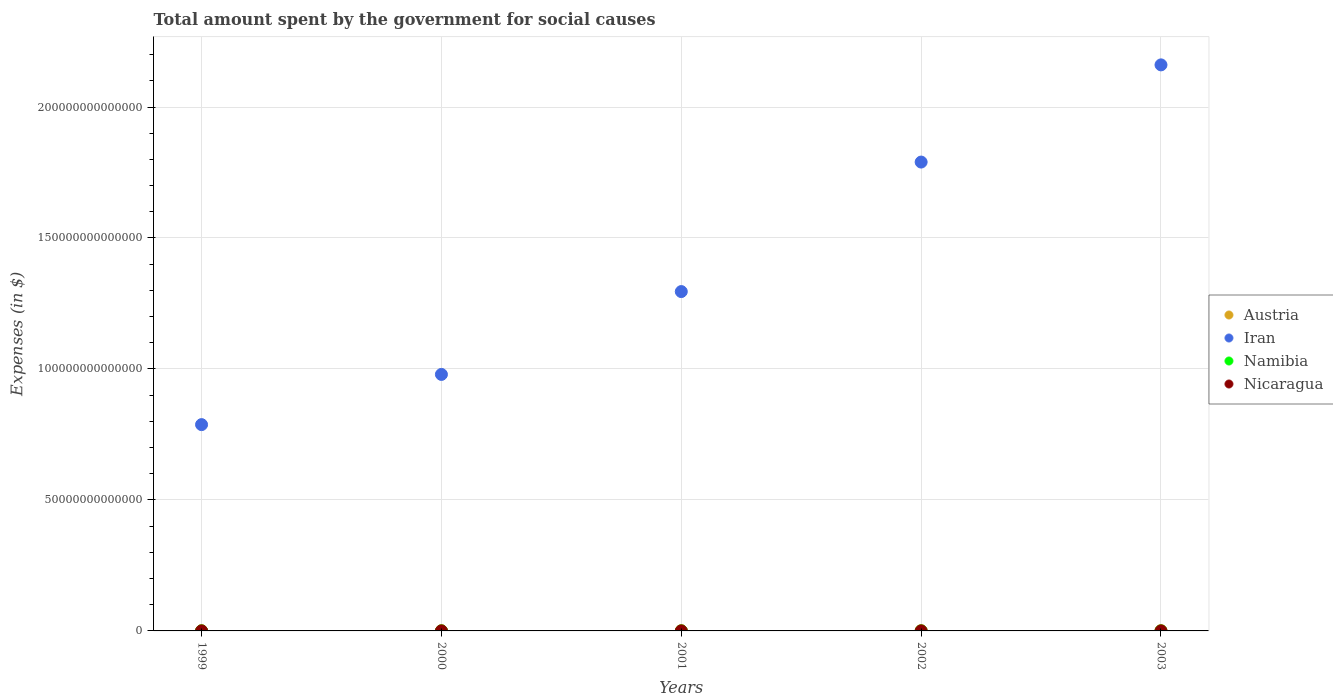How many different coloured dotlines are there?
Ensure brevity in your answer.  4. Is the number of dotlines equal to the number of legend labels?
Your answer should be compact. Yes. What is the amount spent for social causes by the government in Austria in 2002?
Keep it short and to the point. 8.88e+1. Across all years, what is the maximum amount spent for social causes by the government in Austria?
Your answer should be very brief. 9.14e+1. Across all years, what is the minimum amount spent for social causes by the government in Iran?
Ensure brevity in your answer.  7.88e+13. What is the total amount spent for social causes by the government in Iran in the graph?
Make the answer very short. 7.01e+14. What is the difference between the amount spent for social causes by the government in Austria in 2001 and that in 2002?
Your response must be concise. -1.54e+09. What is the difference between the amount spent for social causes by the government in Iran in 2002 and the amount spent for social causes by the government in Austria in 2000?
Your response must be concise. 1.79e+14. What is the average amount spent for social causes by the government in Namibia per year?
Your answer should be compact. 9.03e+09. In the year 2002, what is the difference between the amount spent for social causes by the government in Austria and amount spent for social causes by the government in Iran?
Provide a succinct answer. -1.79e+14. What is the ratio of the amount spent for social causes by the government in Austria in 1999 to that in 2003?
Your answer should be very brief. 0.9. Is the amount spent for social causes by the government in Nicaragua in 1999 less than that in 2001?
Your answer should be compact. Yes. What is the difference between the highest and the second highest amount spent for social causes by the government in Namibia?
Offer a very short reply. 8.63e+08. What is the difference between the highest and the lowest amount spent for social causes by the government in Austria?
Your response must be concise. 9.48e+09. Is the sum of the amount spent for social causes by the government in Iran in 2000 and 2001 greater than the maximum amount spent for social causes by the government in Nicaragua across all years?
Keep it short and to the point. Yes. Is it the case that in every year, the sum of the amount spent for social causes by the government in Nicaragua and amount spent for social causes by the government in Austria  is greater than the sum of amount spent for social causes by the government in Iran and amount spent for social causes by the government in Namibia?
Ensure brevity in your answer.  No. Does the amount spent for social causes by the government in Austria monotonically increase over the years?
Your response must be concise. Yes. Is the amount spent for social causes by the government in Nicaragua strictly less than the amount spent for social causes by the government in Austria over the years?
Offer a terse response. Yes. How many dotlines are there?
Your answer should be very brief. 4. What is the difference between two consecutive major ticks on the Y-axis?
Ensure brevity in your answer.  5.00e+13. How many legend labels are there?
Provide a succinct answer. 4. How are the legend labels stacked?
Your answer should be very brief. Vertical. What is the title of the graph?
Offer a terse response. Total amount spent by the government for social causes. What is the label or title of the X-axis?
Make the answer very short. Years. What is the label or title of the Y-axis?
Your answer should be very brief. Expenses (in $). What is the Expenses (in $) in Austria in 1999?
Provide a succinct answer. 8.19e+1. What is the Expenses (in $) in Iran in 1999?
Offer a very short reply. 7.88e+13. What is the Expenses (in $) of Namibia in 1999?
Your answer should be compact. 6.91e+09. What is the Expenses (in $) in Nicaragua in 1999?
Offer a terse response. 7.27e+09. What is the Expenses (in $) in Austria in 2000?
Offer a very short reply. 8.43e+1. What is the Expenses (in $) in Iran in 2000?
Ensure brevity in your answer.  9.79e+13. What is the Expenses (in $) in Namibia in 2000?
Your answer should be very brief. 7.73e+09. What is the Expenses (in $) in Nicaragua in 2000?
Ensure brevity in your answer.  8.23e+09. What is the Expenses (in $) of Austria in 2001?
Offer a very short reply. 8.72e+1. What is the Expenses (in $) of Iran in 2001?
Make the answer very short. 1.30e+14. What is the Expenses (in $) in Namibia in 2001?
Offer a terse response. 9.20e+09. What is the Expenses (in $) in Nicaragua in 2001?
Provide a short and direct response. 1.03e+1. What is the Expenses (in $) of Austria in 2002?
Your answer should be very brief. 8.88e+1. What is the Expenses (in $) of Iran in 2002?
Keep it short and to the point. 1.79e+14. What is the Expenses (in $) in Namibia in 2002?
Keep it short and to the point. 1.02e+1. What is the Expenses (in $) in Nicaragua in 2002?
Your answer should be compact. 9.08e+09. What is the Expenses (in $) of Austria in 2003?
Offer a terse response. 9.14e+1. What is the Expenses (in $) of Iran in 2003?
Your answer should be very brief. 2.16e+14. What is the Expenses (in $) in Namibia in 2003?
Offer a very short reply. 1.11e+1. What is the Expenses (in $) in Nicaragua in 2003?
Offer a terse response. 1.06e+1. Across all years, what is the maximum Expenses (in $) of Austria?
Provide a short and direct response. 9.14e+1. Across all years, what is the maximum Expenses (in $) in Iran?
Provide a short and direct response. 2.16e+14. Across all years, what is the maximum Expenses (in $) of Namibia?
Ensure brevity in your answer.  1.11e+1. Across all years, what is the maximum Expenses (in $) in Nicaragua?
Your response must be concise. 1.06e+1. Across all years, what is the minimum Expenses (in $) of Austria?
Ensure brevity in your answer.  8.19e+1. Across all years, what is the minimum Expenses (in $) of Iran?
Keep it short and to the point. 7.88e+13. Across all years, what is the minimum Expenses (in $) of Namibia?
Provide a succinct answer. 6.91e+09. Across all years, what is the minimum Expenses (in $) of Nicaragua?
Make the answer very short. 7.27e+09. What is the total Expenses (in $) in Austria in the graph?
Provide a short and direct response. 4.34e+11. What is the total Expenses (in $) of Iran in the graph?
Your response must be concise. 7.01e+14. What is the total Expenses (in $) of Namibia in the graph?
Offer a very short reply. 4.51e+1. What is the total Expenses (in $) in Nicaragua in the graph?
Provide a short and direct response. 4.55e+1. What is the difference between the Expenses (in $) of Austria in 1999 and that in 2000?
Offer a terse response. -2.33e+09. What is the difference between the Expenses (in $) of Iran in 1999 and that in 2000?
Your answer should be very brief. -1.92e+13. What is the difference between the Expenses (in $) in Namibia in 1999 and that in 2000?
Offer a very short reply. -8.13e+08. What is the difference between the Expenses (in $) of Nicaragua in 1999 and that in 2000?
Ensure brevity in your answer.  -9.54e+08. What is the difference between the Expenses (in $) of Austria in 1999 and that in 2001?
Your answer should be very brief. -5.31e+09. What is the difference between the Expenses (in $) of Iran in 1999 and that in 2001?
Your response must be concise. -5.08e+13. What is the difference between the Expenses (in $) in Namibia in 1999 and that in 2001?
Provide a short and direct response. -2.29e+09. What is the difference between the Expenses (in $) in Nicaragua in 1999 and that in 2001?
Offer a terse response. -3.04e+09. What is the difference between the Expenses (in $) in Austria in 1999 and that in 2002?
Provide a succinct answer. -6.85e+09. What is the difference between the Expenses (in $) in Iran in 1999 and that in 2002?
Your answer should be compact. -1.00e+14. What is the difference between the Expenses (in $) of Namibia in 1999 and that in 2002?
Ensure brevity in your answer.  -3.30e+09. What is the difference between the Expenses (in $) of Nicaragua in 1999 and that in 2002?
Keep it short and to the point. -1.81e+09. What is the difference between the Expenses (in $) of Austria in 1999 and that in 2003?
Your response must be concise. -9.48e+09. What is the difference between the Expenses (in $) in Iran in 1999 and that in 2003?
Offer a very short reply. -1.37e+14. What is the difference between the Expenses (in $) of Namibia in 1999 and that in 2003?
Make the answer very short. -4.16e+09. What is the difference between the Expenses (in $) of Nicaragua in 1999 and that in 2003?
Your answer should be compact. -3.30e+09. What is the difference between the Expenses (in $) of Austria in 2000 and that in 2001?
Your response must be concise. -2.98e+09. What is the difference between the Expenses (in $) of Iran in 2000 and that in 2001?
Offer a terse response. -3.16e+13. What is the difference between the Expenses (in $) in Namibia in 2000 and that in 2001?
Offer a very short reply. -1.47e+09. What is the difference between the Expenses (in $) in Nicaragua in 2000 and that in 2001?
Provide a succinct answer. -2.09e+09. What is the difference between the Expenses (in $) of Austria in 2000 and that in 2002?
Your answer should be compact. -4.52e+09. What is the difference between the Expenses (in $) of Iran in 2000 and that in 2002?
Give a very brief answer. -8.11e+13. What is the difference between the Expenses (in $) of Namibia in 2000 and that in 2002?
Keep it short and to the point. -2.49e+09. What is the difference between the Expenses (in $) of Nicaragua in 2000 and that in 2002?
Your answer should be compact. -8.56e+08. What is the difference between the Expenses (in $) of Austria in 2000 and that in 2003?
Offer a terse response. -7.15e+09. What is the difference between the Expenses (in $) in Iran in 2000 and that in 2003?
Give a very brief answer. -1.18e+14. What is the difference between the Expenses (in $) in Namibia in 2000 and that in 2003?
Keep it short and to the point. -3.35e+09. What is the difference between the Expenses (in $) of Nicaragua in 2000 and that in 2003?
Provide a short and direct response. -2.35e+09. What is the difference between the Expenses (in $) in Austria in 2001 and that in 2002?
Keep it short and to the point. -1.54e+09. What is the difference between the Expenses (in $) in Iran in 2001 and that in 2002?
Keep it short and to the point. -4.94e+13. What is the difference between the Expenses (in $) of Namibia in 2001 and that in 2002?
Ensure brevity in your answer.  -1.01e+09. What is the difference between the Expenses (in $) of Nicaragua in 2001 and that in 2002?
Give a very brief answer. 1.23e+09. What is the difference between the Expenses (in $) of Austria in 2001 and that in 2003?
Your response must be concise. -4.17e+09. What is the difference between the Expenses (in $) in Iran in 2001 and that in 2003?
Provide a short and direct response. -8.65e+13. What is the difference between the Expenses (in $) in Namibia in 2001 and that in 2003?
Make the answer very short. -1.88e+09. What is the difference between the Expenses (in $) in Nicaragua in 2001 and that in 2003?
Keep it short and to the point. -2.57e+08. What is the difference between the Expenses (in $) of Austria in 2002 and that in 2003?
Your answer should be compact. -2.63e+09. What is the difference between the Expenses (in $) of Iran in 2002 and that in 2003?
Offer a terse response. -3.71e+13. What is the difference between the Expenses (in $) of Namibia in 2002 and that in 2003?
Ensure brevity in your answer.  -8.63e+08. What is the difference between the Expenses (in $) in Nicaragua in 2002 and that in 2003?
Your answer should be very brief. -1.49e+09. What is the difference between the Expenses (in $) in Austria in 1999 and the Expenses (in $) in Iran in 2000?
Make the answer very short. -9.78e+13. What is the difference between the Expenses (in $) in Austria in 1999 and the Expenses (in $) in Namibia in 2000?
Ensure brevity in your answer.  7.42e+1. What is the difference between the Expenses (in $) of Austria in 1999 and the Expenses (in $) of Nicaragua in 2000?
Provide a succinct answer. 7.37e+1. What is the difference between the Expenses (in $) of Iran in 1999 and the Expenses (in $) of Namibia in 2000?
Offer a very short reply. 7.87e+13. What is the difference between the Expenses (in $) of Iran in 1999 and the Expenses (in $) of Nicaragua in 2000?
Ensure brevity in your answer.  7.87e+13. What is the difference between the Expenses (in $) in Namibia in 1999 and the Expenses (in $) in Nicaragua in 2000?
Make the answer very short. -1.31e+09. What is the difference between the Expenses (in $) of Austria in 1999 and the Expenses (in $) of Iran in 2001?
Give a very brief answer. -1.29e+14. What is the difference between the Expenses (in $) in Austria in 1999 and the Expenses (in $) in Namibia in 2001?
Make the answer very short. 7.27e+1. What is the difference between the Expenses (in $) of Austria in 1999 and the Expenses (in $) of Nicaragua in 2001?
Ensure brevity in your answer.  7.16e+1. What is the difference between the Expenses (in $) of Iran in 1999 and the Expenses (in $) of Namibia in 2001?
Keep it short and to the point. 7.87e+13. What is the difference between the Expenses (in $) in Iran in 1999 and the Expenses (in $) in Nicaragua in 2001?
Provide a succinct answer. 7.87e+13. What is the difference between the Expenses (in $) of Namibia in 1999 and the Expenses (in $) of Nicaragua in 2001?
Your response must be concise. -3.40e+09. What is the difference between the Expenses (in $) in Austria in 1999 and the Expenses (in $) in Iran in 2002?
Offer a terse response. -1.79e+14. What is the difference between the Expenses (in $) in Austria in 1999 and the Expenses (in $) in Namibia in 2002?
Your answer should be compact. 7.17e+1. What is the difference between the Expenses (in $) of Austria in 1999 and the Expenses (in $) of Nicaragua in 2002?
Give a very brief answer. 7.29e+1. What is the difference between the Expenses (in $) in Iran in 1999 and the Expenses (in $) in Namibia in 2002?
Ensure brevity in your answer.  7.87e+13. What is the difference between the Expenses (in $) in Iran in 1999 and the Expenses (in $) in Nicaragua in 2002?
Ensure brevity in your answer.  7.87e+13. What is the difference between the Expenses (in $) in Namibia in 1999 and the Expenses (in $) in Nicaragua in 2002?
Provide a succinct answer. -2.17e+09. What is the difference between the Expenses (in $) in Austria in 1999 and the Expenses (in $) in Iran in 2003?
Keep it short and to the point. -2.16e+14. What is the difference between the Expenses (in $) in Austria in 1999 and the Expenses (in $) in Namibia in 2003?
Your answer should be very brief. 7.09e+1. What is the difference between the Expenses (in $) of Austria in 1999 and the Expenses (in $) of Nicaragua in 2003?
Make the answer very short. 7.14e+1. What is the difference between the Expenses (in $) of Iran in 1999 and the Expenses (in $) of Namibia in 2003?
Your answer should be compact. 7.87e+13. What is the difference between the Expenses (in $) of Iran in 1999 and the Expenses (in $) of Nicaragua in 2003?
Give a very brief answer. 7.87e+13. What is the difference between the Expenses (in $) in Namibia in 1999 and the Expenses (in $) in Nicaragua in 2003?
Ensure brevity in your answer.  -3.66e+09. What is the difference between the Expenses (in $) in Austria in 2000 and the Expenses (in $) in Iran in 2001?
Provide a short and direct response. -1.29e+14. What is the difference between the Expenses (in $) in Austria in 2000 and the Expenses (in $) in Namibia in 2001?
Offer a terse response. 7.51e+1. What is the difference between the Expenses (in $) of Austria in 2000 and the Expenses (in $) of Nicaragua in 2001?
Ensure brevity in your answer.  7.39e+1. What is the difference between the Expenses (in $) of Iran in 2000 and the Expenses (in $) of Namibia in 2001?
Your answer should be very brief. 9.79e+13. What is the difference between the Expenses (in $) in Iran in 2000 and the Expenses (in $) in Nicaragua in 2001?
Provide a short and direct response. 9.79e+13. What is the difference between the Expenses (in $) in Namibia in 2000 and the Expenses (in $) in Nicaragua in 2001?
Make the answer very short. -2.59e+09. What is the difference between the Expenses (in $) in Austria in 2000 and the Expenses (in $) in Iran in 2002?
Offer a very short reply. -1.79e+14. What is the difference between the Expenses (in $) of Austria in 2000 and the Expenses (in $) of Namibia in 2002?
Your answer should be compact. 7.41e+1. What is the difference between the Expenses (in $) in Austria in 2000 and the Expenses (in $) in Nicaragua in 2002?
Offer a very short reply. 7.52e+1. What is the difference between the Expenses (in $) in Iran in 2000 and the Expenses (in $) in Namibia in 2002?
Your answer should be compact. 9.79e+13. What is the difference between the Expenses (in $) of Iran in 2000 and the Expenses (in $) of Nicaragua in 2002?
Your response must be concise. 9.79e+13. What is the difference between the Expenses (in $) of Namibia in 2000 and the Expenses (in $) of Nicaragua in 2002?
Offer a very short reply. -1.36e+09. What is the difference between the Expenses (in $) of Austria in 2000 and the Expenses (in $) of Iran in 2003?
Offer a very short reply. -2.16e+14. What is the difference between the Expenses (in $) in Austria in 2000 and the Expenses (in $) in Namibia in 2003?
Give a very brief answer. 7.32e+1. What is the difference between the Expenses (in $) of Austria in 2000 and the Expenses (in $) of Nicaragua in 2003?
Your answer should be very brief. 7.37e+1. What is the difference between the Expenses (in $) in Iran in 2000 and the Expenses (in $) in Namibia in 2003?
Keep it short and to the point. 9.79e+13. What is the difference between the Expenses (in $) in Iran in 2000 and the Expenses (in $) in Nicaragua in 2003?
Ensure brevity in your answer.  9.79e+13. What is the difference between the Expenses (in $) of Namibia in 2000 and the Expenses (in $) of Nicaragua in 2003?
Give a very brief answer. -2.85e+09. What is the difference between the Expenses (in $) in Austria in 2001 and the Expenses (in $) in Iran in 2002?
Keep it short and to the point. -1.79e+14. What is the difference between the Expenses (in $) in Austria in 2001 and the Expenses (in $) in Namibia in 2002?
Ensure brevity in your answer.  7.70e+1. What is the difference between the Expenses (in $) of Austria in 2001 and the Expenses (in $) of Nicaragua in 2002?
Your answer should be compact. 7.82e+1. What is the difference between the Expenses (in $) in Iran in 2001 and the Expenses (in $) in Namibia in 2002?
Your answer should be compact. 1.30e+14. What is the difference between the Expenses (in $) of Iran in 2001 and the Expenses (in $) of Nicaragua in 2002?
Give a very brief answer. 1.30e+14. What is the difference between the Expenses (in $) of Namibia in 2001 and the Expenses (in $) of Nicaragua in 2002?
Give a very brief answer. 1.17e+08. What is the difference between the Expenses (in $) of Austria in 2001 and the Expenses (in $) of Iran in 2003?
Ensure brevity in your answer.  -2.16e+14. What is the difference between the Expenses (in $) of Austria in 2001 and the Expenses (in $) of Namibia in 2003?
Offer a very short reply. 7.62e+1. What is the difference between the Expenses (in $) in Austria in 2001 and the Expenses (in $) in Nicaragua in 2003?
Keep it short and to the point. 7.67e+1. What is the difference between the Expenses (in $) in Iran in 2001 and the Expenses (in $) in Namibia in 2003?
Your answer should be very brief. 1.30e+14. What is the difference between the Expenses (in $) in Iran in 2001 and the Expenses (in $) in Nicaragua in 2003?
Your answer should be compact. 1.30e+14. What is the difference between the Expenses (in $) of Namibia in 2001 and the Expenses (in $) of Nicaragua in 2003?
Your answer should be very brief. -1.37e+09. What is the difference between the Expenses (in $) of Austria in 2002 and the Expenses (in $) of Iran in 2003?
Ensure brevity in your answer.  -2.16e+14. What is the difference between the Expenses (in $) of Austria in 2002 and the Expenses (in $) of Namibia in 2003?
Your answer should be very brief. 7.77e+1. What is the difference between the Expenses (in $) in Austria in 2002 and the Expenses (in $) in Nicaragua in 2003?
Offer a very short reply. 7.82e+1. What is the difference between the Expenses (in $) in Iran in 2002 and the Expenses (in $) in Namibia in 2003?
Provide a short and direct response. 1.79e+14. What is the difference between the Expenses (in $) of Iran in 2002 and the Expenses (in $) of Nicaragua in 2003?
Keep it short and to the point. 1.79e+14. What is the difference between the Expenses (in $) in Namibia in 2002 and the Expenses (in $) in Nicaragua in 2003?
Make the answer very short. -3.58e+08. What is the average Expenses (in $) in Austria per year?
Your answer should be compact. 8.67e+1. What is the average Expenses (in $) in Iran per year?
Make the answer very short. 1.40e+14. What is the average Expenses (in $) of Namibia per year?
Offer a terse response. 9.03e+09. What is the average Expenses (in $) in Nicaragua per year?
Provide a succinct answer. 9.09e+09. In the year 1999, what is the difference between the Expenses (in $) in Austria and Expenses (in $) in Iran?
Ensure brevity in your answer.  -7.87e+13. In the year 1999, what is the difference between the Expenses (in $) in Austria and Expenses (in $) in Namibia?
Make the answer very short. 7.50e+1. In the year 1999, what is the difference between the Expenses (in $) of Austria and Expenses (in $) of Nicaragua?
Keep it short and to the point. 7.47e+1. In the year 1999, what is the difference between the Expenses (in $) in Iran and Expenses (in $) in Namibia?
Make the answer very short. 7.87e+13. In the year 1999, what is the difference between the Expenses (in $) of Iran and Expenses (in $) of Nicaragua?
Offer a terse response. 7.87e+13. In the year 1999, what is the difference between the Expenses (in $) of Namibia and Expenses (in $) of Nicaragua?
Ensure brevity in your answer.  -3.59e+08. In the year 2000, what is the difference between the Expenses (in $) in Austria and Expenses (in $) in Iran?
Your answer should be compact. -9.78e+13. In the year 2000, what is the difference between the Expenses (in $) in Austria and Expenses (in $) in Namibia?
Your response must be concise. 7.65e+1. In the year 2000, what is the difference between the Expenses (in $) in Austria and Expenses (in $) in Nicaragua?
Your answer should be very brief. 7.60e+1. In the year 2000, what is the difference between the Expenses (in $) of Iran and Expenses (in $) of Namibia?
Ensure brevity in your answer.  9.79e+13. In the year 2000, what is the difference between the Expenses (in $) in Iran and Expenses (in $) in Nicaragua?
Offer a terse response. 9.79e+13. In the year 2000, what is the difference between the Expenses (in $) of Namibia and Expenses (in $) of Nicaragua?
Make the answer very short. -5.00e+08. In the year 2001, what is the difference between the Expenses (in $) in Austria and Expenses (in $) in Iran?
Give a very brief answer. -1.29e+14. In the year 2001, what is the difference between the Expenses (in $) of Austria and Expenses (in $) of Namibia?
Your answer should be compact. 7.80e+1. In the year 2001, what is the difference between the Expenses (in $) of Austria and Expenses (in $) of Nicaragua?
Your answer should be compact. 7.69e+1. In the year 2001, what is the difference between the Expenses (in $) in Iran and Expenses (in $) in Namibia?
Offer a terse response. 1.30e+14. In the year 2001, what is the difference between the Expenses (in $) in Iran and Expenses (in $) in Nicaragua?
Give a very brief answer. 1.30e+14. In the year 2001, what is the difference between the Expenses (in $) in Namibia and Expenses (in $) in Nicaragua?
Offer a terse response. -1.12e+09. In the year 2002, what is the difference between the Expenses (in $) in Austria and Expenses (in $) in Iran?
Offer a terse response. -1.79e+14. In the year 2002, what is the difference between the Expenses (in $) in Austria and Expenses (in $) in Namibia?
Keep it short and to the point. 7.86e+1. In the year 2002, what is the difference between the Expenses (in $) of Austria and Expenses (in $) of Nicaragua?
Make the answer very short. 7.97e+1. In the year 2002, what is the difference between the Expenses (in $) of Iran and Expenses (in $) of Namibia?
Ensure brevity in your answer.  1.79e+14. In the year 2002, what is the difference between the Expenses (in $) in Iran and Expenses (in $) in Nicaragua?
Ensure brevity in your answer.  1.79e+14. In the year 2002, what is the difference between the Expenses (in $) in Namibia and Expenses (in $) in Nicaragua?
Your response must be concise. 1.13e+09. In the year 2003, what is the difference between the Expenses (in $) of Austria and Expenses (in $) of Iran?
Your response must be concise. -2.16e+14. In the year 2003, what is the difference between the Expenses (in $) in Austria and Expenses (in $) in Namibia?
Give a very brief answer. 8.03e+1. In the year 2003, what is the difference between the Expenses (in $) of Austria and Expenses (in $) of Nicaragua?
Keep it short and to the point. 8.08e+1. In the year 2003, what is the difference between the Expenses (in $) in Iran and Expenses (in $) in Namibia?
Your response must be concise. 2.16e+14. In the year 2003, what is the difference between the Expenses (in $) in Iran and Expenses (in $) in Nicaragua?
Give a very brief answer. 2.16e+14. In the year 2003, what is the difference between the Expenses (in $) of Namibia and Expenses (in $) of Nicaragua?
Offer a very short reply. 5.05e+08. What is the ratio of the Expenses (in $) in Austria in 1999 to that in 2000?
Offer a very short reply. 0.97. What is the ratio of the Expenses (in $) of Iran in 1999 to that in 2000?
Offer a terse response. 0.8. What is the ratio of the Expenses (in $) in Namibia in 1999 to that in 2000?
Your answer should be compact. 0.89. What is the ratio of the Expenses (in $) of Nicaragua in 1999 to that in 2000?
Your response must be concise. 0.88. What is the ratio of the Expenses (in $) in Austria in 1999 to that in 2001?
Offer a terse response. 0.94. What is the ratio of the Expenses (in $) of Iran in 1999 to that in 2001?
Keep it short and to the point. 0.61. What is the ratio of the Expenses (in $) of Namibia in 1999 to that in 2001?
Ensure brevity in your answer.  0.75. What is the ratio of the Expenses (in $) of Nicaragua in 1999 to that in 2001?
Offer a very short reply. 0.7. What is the ratio of the Expenses (in $) of Austria in 1999 to that in 2002?
Make the answer very short. 0.92. What is the ratio of the Expenses (in $) in Iran in 1999 to that in 2002?
Offer a very short reply. 0.44. What is the ratio of the Expenses (in $) of Namibia in 1999 to that in 2002?
Your response must be concise. 0.68. What is the ratio of the Expenses (in $) of Nicaragua in 1999 to that in 2002?
Your answer should be very brief. 0.8. What is the ratio of the Expenses (in $) in Austria in 1999 to that in 2003?
Give a very brief answer. 0.9. What is the ratio of the Expenses (in $) of Iran in 1999 to that in 2003?
Offer a terse response. 0.36. What is the ratio of the Expenses (in $) of Namibia in 1999 to that in 2003?
Make the answer very short. 0.62. What is the ratio of the Expenses (in $) of Nicaragua in 1999 to that in 2003?
Give a very brief answer. 0.69. What is the ratio of the Expenses (in $) in Austria in 2000 to that in 2001?
Offer a very short reply. 0.97. What is the ratio of the Expenses (in $) in Iran in 2000 to that in 2001?
Provide a short and direct response. 0.76. What is the ratio of the Expenses (in $) of Namibia in 2000 to that in 2001?
Keep it short and to the point. 0.84. What is the ratio of the Expenses (in $) of Nicaragua in 2000 to that in 2001?
Offer a very short reply. 0.8. What is the ratio of the Expenses (in $) of Austria in 2000 to that in 2002?
Provide a succinct answer. 0.95. What is the ratio of the Expenses (in $) in Iran in 2000 to that in 2002?
Keep it short and to the point. 0.55. What is the ratio of the Expenses (in $) of Namibia in 2000 to that in 2002?
Your response must be concise. 0.76. What is the ratio of the Expenses (in $) in Nicaragua in 2000 to that in 2002?
Provide a succinct answer. 0.91. What is the ratio of the Expenses (in $) of Austria in 2000 to that in 2003?
Offer a terse response. 0.92. What is the ratio of the Expenses (in $) in Iran in 2000 to that in 2003?
Offer a terse response. 0.45. What is the ratio of the Expenses (in $) of Namibia in 2000 to that in 2003?
Ensure brevity in your answer.  0.7. What is the ratio of the Expenses (in $) in Nicaragua in 2000 to that in 2003?
Offer a very short reply. 0.78. What is the ratio of the Expenses (in $) of Austria in 2001 to that in 2002?
Your answer should be very brief. 0.98. What is the ratio of the Expenses (in $) of Iran in 2001 to that in 2002?
Offer a terse response. 0.72. What is the ratio of the Expenses (in $) in Namibia in 2001 to that in 2002?
Your answer should be very brief. 0.9. What is the ratio of the Expenses (in $) of Nicaragua in 2001 to that in 2002?
Keep it short and to the point. 1.14. What is the ratio of the Expenses (in $) in Austria in 2001 to that in 2003?
Your answer should be very brief. 0.95. What is the ratio of the Expenses (in $) of Iran in 2001 to that in 2003?
Your answer should be compact. 0.6. What is the ratio of the Expenses (in $) of Namibia in 2001 to that in 2003?
Give a very brief answer. 0.83. What is the ratio of the Expenses (in $) of Nicaragua in 2001 to that in 2003?
Make the answer very short. 0.98. What is the ratio of the Expenses (in $) in Austria in 2002 to that in 2003?
Ensure brevity in your answer.  0.97. What is the ratio of the Expenses (in $) of Iran in 2002 to that in 2003?
Provide a short and direct response. 0.83. What is the ratio of the Expenses (in $) in Namibia in 2002 to that in 2003?
Offer a terse response. 0.92. What is the ratio of the Expenses (in $) in Nicaragua in 2002 to that in 2003?
Your response must be concise. 0.86. What is the difference between the highest and the second highest Expenses (in $) in Austria?
Your answer should be compact. 2.63e+09. What is the difference between the highest and the second highest Expenses (in $) in Iran?
Your answer should be very brief. 3.71e+13. What is the difference between the highest and the second highest Expenses (in $) in Namibia?
Your answer should be compact. 8.63e+08. What is the difference between the highest and the second highest Expenses (in $) in Nicaragua?
Your answer should be very brief. 2.57e+08. What is the difference between the highest and the lowest Expenses (in $) of Austria?
Provide a succinct answer. 9.48e+09. What is the difference between the highest and the lowest Expenses (in $) in Iran?
Your response must be concise. 1.37e+14. What is the difference between the highest and the lowest Expenses (in $) in Namibia?
Give a very brief answer. 4.16e+09. What is the difference between the highest and the lowest Expenses (in $) of Nicaragua?
Make the answer very short. 3.30e+09. 